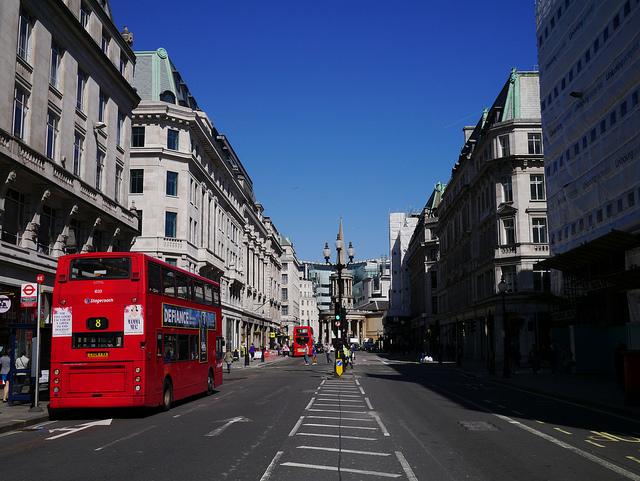Is this picture taken in the night?
Keep it brief. No. Are there any vehicles in the street?
Keep it brief. Yes. Is this a double decker bus?
Quick response, please. Yes. How many red buses are there?
Give a very brief answer. 2. Is it day or nighttime?
Concise answer only. Day. What color is the double decker bus?
Write a very short answer. Red. 